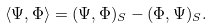Convert formula to latex. <formula><loc_0><loc_0><loc_500><loc_500>\langle \Psi , \Phi \rangle = ( \Psi , \Phi ) _ { S } - ( \Phi , \Psi ) _ { S } .</formula> 